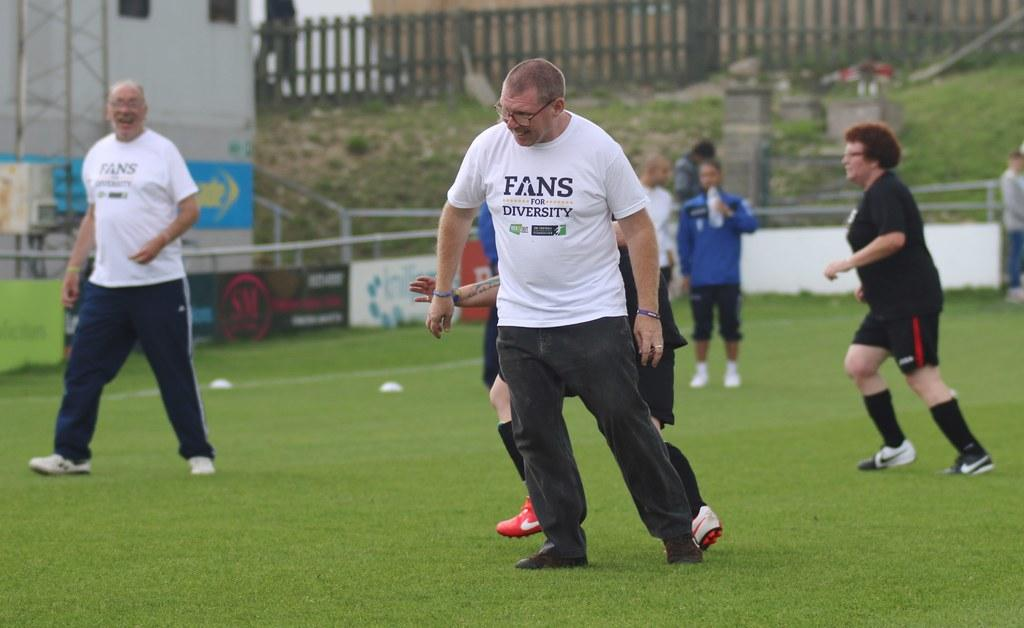<image>
Render a clear and concise summary of the photo. Several people are participating in sports on a green field, wearing T-shirts for the Fans For Diversity cause. 